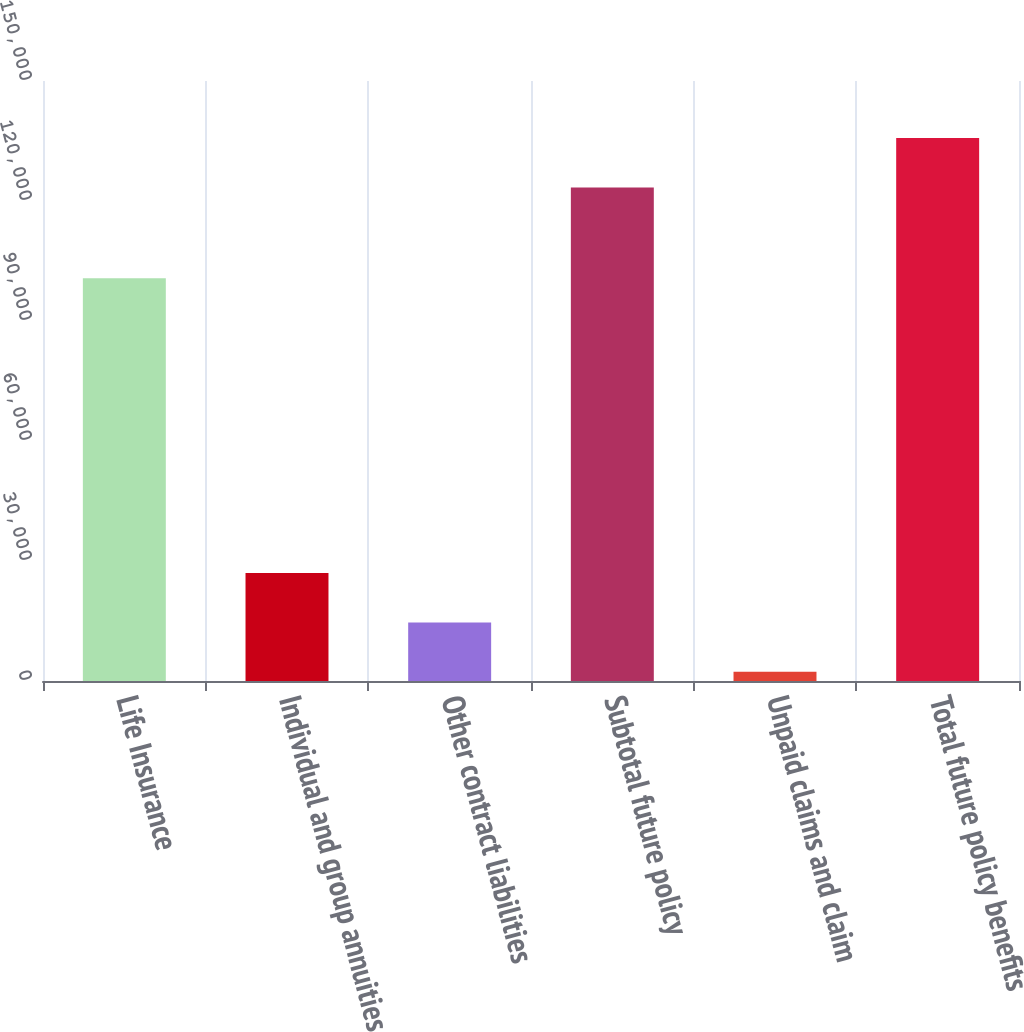<chart> <loc_0><loc_0><loc_500><loc_500><bar_chart><fcel>Life Insurance<fcel>Individual and group annuities<fcel>Other contract liabilities<fcel>Subtotal future policy<fcel>Unpaid claims and claim<fcel>Total future policy benefits<nl><fcel>100686<fcel>26985.4<fcel>14645.2<fcel>123402<fcel>2305<fcel>135742<nl></chart> 